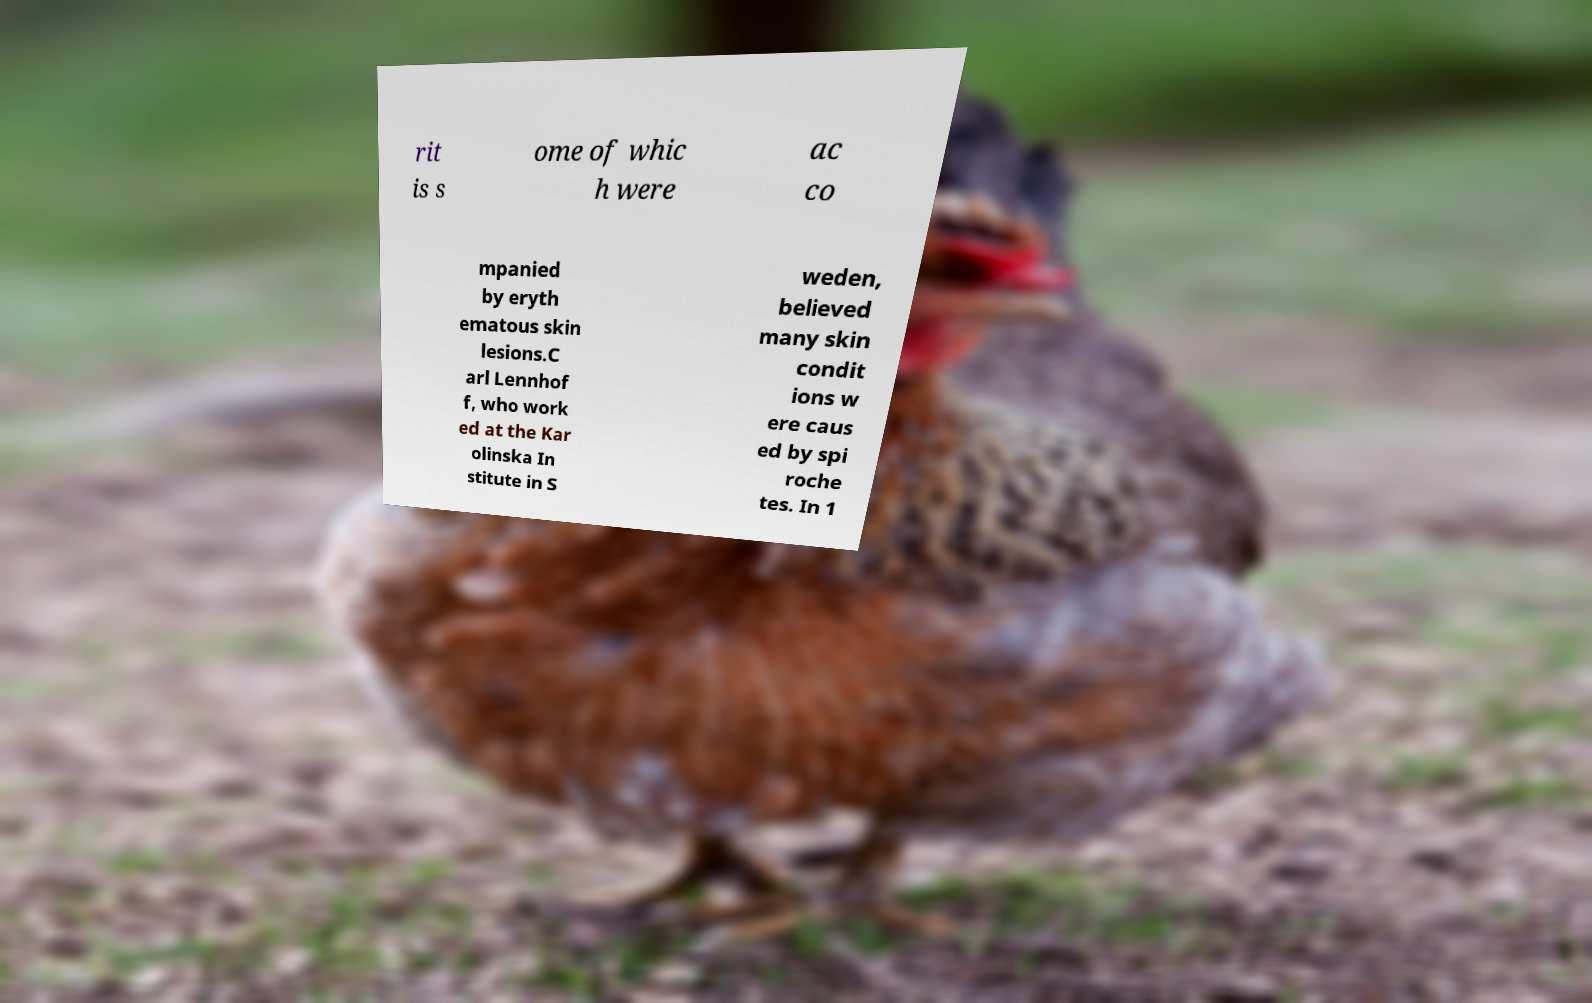For documentation purposes, I need the text within this image transcribed. Could you provide that? rit is s ome of whic h were ac co mpanied by eryth ematous skin lesions.C arl Lennhof f, who work ed at the Kar olinska In stitute in S weden, believed many skin condit ions w ere caus ed by spi roche tes. In 1 